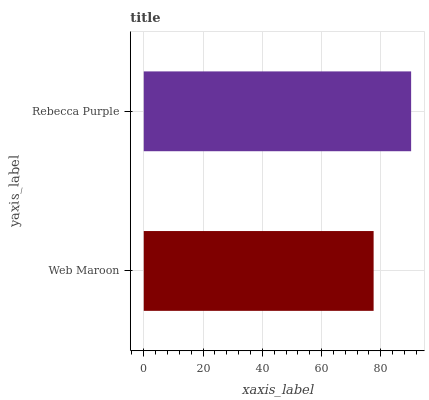Is Web Maroon the minimum?
Answer yes or no. Yes. Is Rebecca Purple the maximum?
Answer yes or no. Yes. Is Rebecca Purple the minimum?
Answer yes or no. No. Is Rebecca Purple greater than Web Maroon?
Answer yes or no. Yes. Is Web Maroon less than Rebecca Purple?
Answer yes or no. Yes. Is Web Maroon greater than Rebecca Purple?
Answer yes or no. No. Is Rebecca Purple less than Web Maroon?
Answer yes or no. No. Is Rebecca Purple the high median?
Answer yes or no. Yes. Is Web Maroon the low median?
Answer yes or no. Yes. Is Web Maroon the high median?
Answer yes or no. No. Is Rebecca Purple the low median?
Answer yes or no. No. 